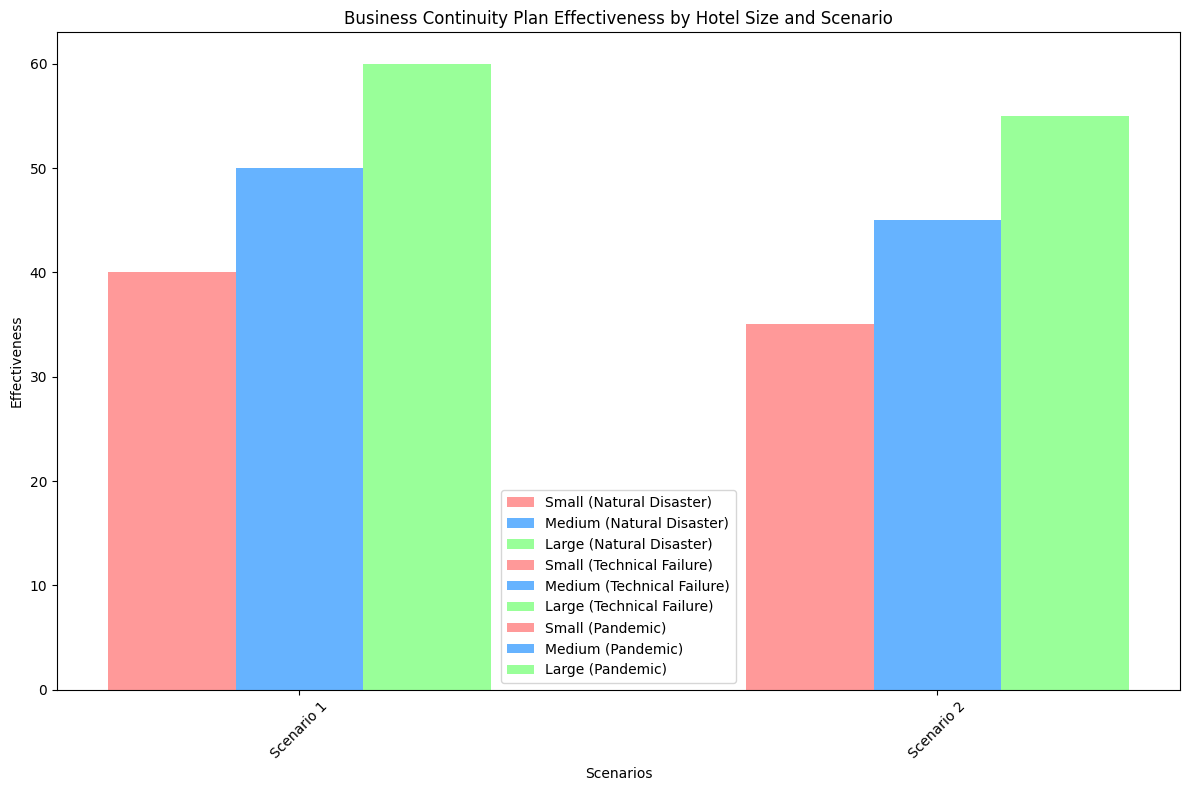Which hotel size had the most effective business continuity plan in Natural Disaster Scenario 1? Look for the highest bar related to Natural Disaster Scenario 1. Large hotels had the highest effectiveness, indicated by the tallest bars.
Answer: Large hotels In which scenario did small hotels have the least effective plans for Technical Failures? Compare the heights of bars for small hotels in both Technical Failure scenarios. The bar for Scenario 2 is shorter than for Scenario 1, indicating fewer effective plans.
Answer: Scenario 2 By how many units does the effectiveness of Large hotels in Natural Disaster Scenario 2 exceed Medium hotels in the same scenario? The effectiveness for Large hotels in Natural Disaster Scenario 2 is 55, while for Medium hotels it is 45. Subtract 45 from 55.
Answer: 10 units How do Medium hotels compare in effectiveness across Pandemic scenarios? Check the heights of the bars for Medium hotels in both Pandemic scenarios. Scenario 1 has an effectiveness of 30, and Scenario 2 has an effectiveness of 25. Scenario 1 is higher.
Answer: Scenario 1 is more effective Which category has the smallest difference in effectiveness between Small and Large hotels in Scenario 1? Calculate the differences for Scenario 1 in each category: 
- Natural Disaster: Large (60) - Small (40) = 20
- Technical Failure: Large (50) - Small (30) = 20
- Pandemic: Large (40) - Small (20) = 20
All categories have the same difference.
Answer: All categories (20 units difference) What is the average effectiveness of Medium hotels across all scenarios in the Natural Disaster category? Add Medium hotels' effectiveness in Natural Disaster Scenario 1 (50) and Scenario 2 (45) and divide by the number of scenarios (2). (50 + 45) / 2 = 47.5.
Answer: 47.5 Which hotel size shows the largest decline in effectiveness from Scenario 1 to Scenario 2 in the Pandemic category? Compare the effectiveness decline for each hotel size in Pandemic category: 
- Small: 20 to 15 (-5)
- Medium: 30 to 25 (-5)
- Large: 40 to 35 (-5)
All sizes have the same decline.
Answer: All hotels (5 units decline) Which scenario had the highest effectiveness for Small hotels under Natural Disaster conditions? Natural Disaster Scenario 1 or Natural Disaster Scenario 2? Compare the heights of the bars for small hotels in Natural Disaster Scenarios. Scenario 1 has an effectiveness of 40 and Scenario 2 an effectiveness of 35. The first scenario is higher.
Answer: Scenario 1 Is the effectiveness of business continuity plans for Large hotels better in Technical Failures or Natural Disasters in Scenario 1? Compare the heights of the bars for Large hotels in Scenario 1 of both categories. Natural Disaster has an effectiveness of 60, while Technical Failure has an effectiveness of 50. Natural Disaster is higher.
Answer: Natural Disasters What is the combined effectiveness of Small hotels in both scenarios of the Pandemic category? Add the effectiveness of Small hotels in both scenarios under the Pandemic category. 20 (Scenario 1) + 15 (Scenario 2) = 35.
Answer: 35 